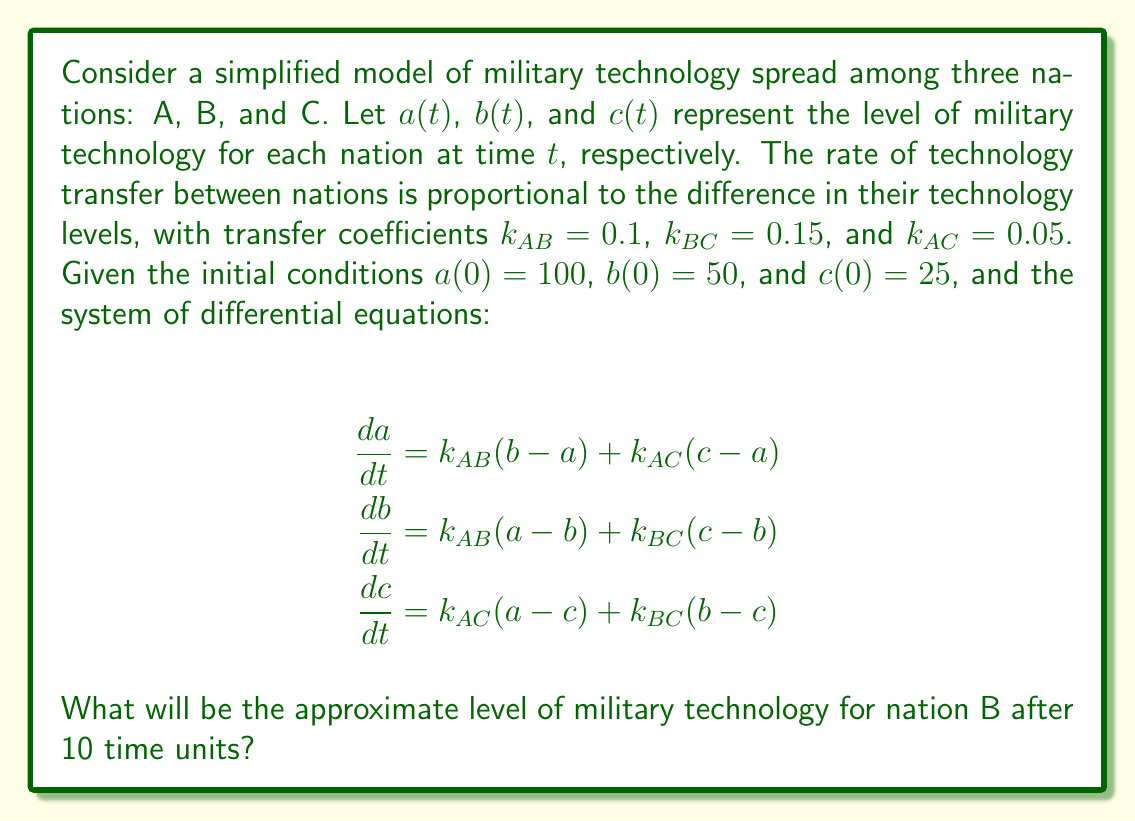Can you solve this math problem? To solve this problem, we need to use numerical methods to approximate the solution of the system of differential equations. We'll use the Euler method with a small time step for simplicity.

Step 1: Set up the Euler method
We'll use a time step of $\Delta t = 0.1$ and iterate 100 times to reach $t=10$.

Step 2: Define the rate equations
$$\begin{align}
f_a(a,b,c) &= 0.1(b-a) + 0.05(c-a) \\
f_b(a,b,c) &= 0.1(a-b) + 0.15(c-b) \\
f_c(a,b,c) &= 0.05(a-c) + 0.15(b-c)
\end{align}$$

Step 3: Implement the Euler method
Initialize: $a_0=100$, $b_0=50$, $c_0=25$
For $i=0$ to $99$:
$$\begin{align}
a_{i+1} &= a_i + \Delta t \cdot f_a(a_i,b_i,c_i) \\
b_{i+1} &= b_i + \Delta t \cdot f_b(a_i,b_i,c_i) \\
c_{i+1} &= c_i + \Delta t \cdot f_c(a_i,b_i,c_i)
\end{align}$$

Step 4: Perform the iterations (showing first few and last few)
$i=0$: $a_1=98.75$, $b_1=52.5$, $c_1=26.5$
$i=1$: $a_2=97.59$, $b_2=54.84$, $c_2=27.91$
...
$i=98$: $a_{99}=71.76$, $b_{99}=70.39$, $c_{99}=68.39$
$i=99$: $a_{100}=71.74$, $b_{100}=70.41$, $c_{100}=68.43$

Step 5: Round the final value of $b$ to two decimal places
$b(10) \approx 70.41$

This result shows that after 10 time units, the military technology level of nation B has increased from its initial value of 50 to approximately 70.41, converging towards the levels of the other nations.
Answer: 70.41 